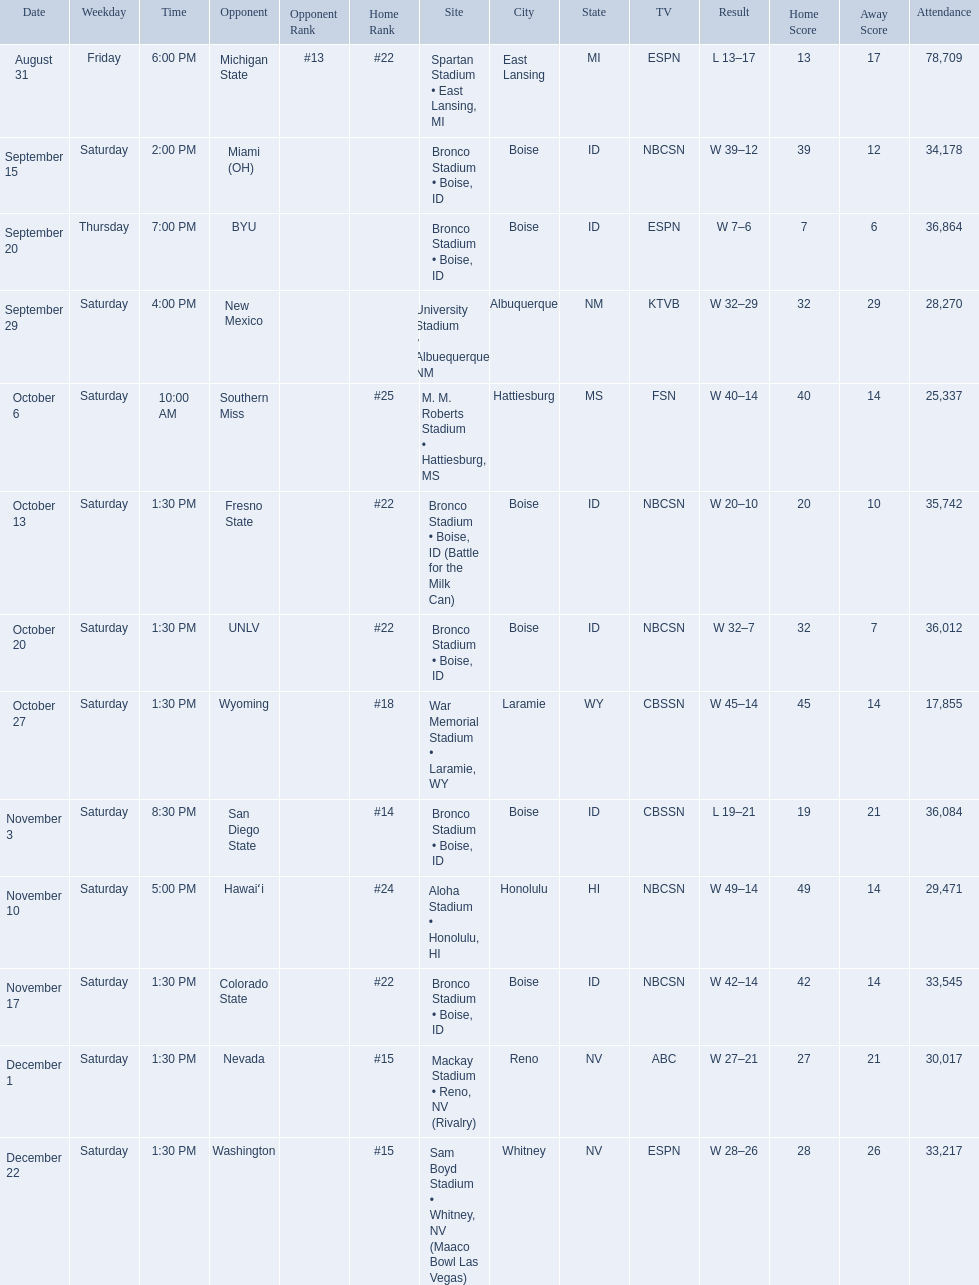Who were all of the opponents? At #13 michigan state*, miami (oh)*, byu*, at new mexico, at southern miss*, fresno state, unlv, at wyoming, san diego state, at hawaiʻi, colorado state, at nevada, vs. washington*. Who did they face on november 3rd? San Diego State. Can you parse all the data within this table? {'header': ['Date', 'Weekday', 'Time', 'Opponent', 'Opponent Rank', 'Home Rank', 'Site', 'City', 'State', 'TV', 'Result', 'Home Score', 'Away Score', 'Attendance'], 'rows': [['August 31', 'Friday', '6:00 PM', 'Michigan State', '#13', '#22', 'Spartan Stadium • East Lansing, MI', 'East Lansing', 'MI', 'ESPN', 'L\xa013–17', '13', '17', '78,709'], ['September 15', 'Saturday', '2:00 PM', 'Miami (OH)', '', '', 'Bronco Stadium • Boise, ID', 'Boise', 'ID', 'NBCSN', 'W\xa039–12', '39', '12', '34,178'], ['September 20', 'Thursday', '7:00 PM', 'BYU', '', '', 'Bronco Stadium • Boise, ID', 'Boise', 'ID', 'ESPN', 'W\xa07–6', '7', '6', '36,864'], ['September 29', 'Saturday', '4:00 PM', 'New Mexico', '', '', 'University Stadium • Albuequerque, NM', 'Albuquerque', 'NM', 'KTVB', 'W\xa032–29', '32', '29', '28,270'], ['October 6', 'Saturday', '10:00 AM', 'Southern Miss', '', '#25', 'M. M. Roberts Stadium • Hattiesburg, MS', 'Hattiesburg', 'MS', 'FSN', 'W\xa040–14', '40', '14', '25,337'], ['October 13', 'Saturday', '1:30 PM', 'Fresno State', '', '#22', 'Bronco Stadium • Boise, ID (Battle for the Milk Can)', 'Boise', 'ID', 'NBCSN', 'W\xa020–10', '20', '10', '35,742'], ['October 20', 'Saturday', '1:30 PM', 'UNLV', '', '#22', 'Bronco Stadium • Boise, ID', 'Boise', 'ID', 'NBCSN', 'W\xa032–7', '32', '7', '36,012'], ['October 27', 'Saturday', '1:30 PM', 'Wyoming', '', '#18', 'War Memorial Stadium • Laramie, WY', 'Laramie', 'WY', 'CBSSN', 'W\xa045–14', '45', '14', '17,855'], ['November 3', 'Saturday', '8:30 PM', 'San Diego State', '', '#14', 'Bronco Stadium • Boise, ID', 'Boise', 'ID', 'CBSSN', 'L\xa019–21', '19', '21', '36,084'], ['November 10', 'Saturday', '5:00 PM', 'Hawaiʻi', '', '#24', 'Aloha Stadium • Honolulu, HI', 'Honolulu', 'HI', 'NBCSN', 'W\xa049–14', '49', '14', '29,471'], ['November 17', 'Saturday', '1:30 PM', 'Colorado State', '', '#22', 'Bronco Stadium • Boise, ID', 'Boise', 'ID', 'NBCSN', 'W\xa042–14', '42', '14', '33,545'], ['December 1', 'Saturday', '1:30 PM', 'Nevada', '', '#15', 'Mackay Stadium • Reno, NV (Rivalry)', 'Reno', 'NV', 'ABC', 'W\xa027–21', '27', '21', '30,017'], ['December 22', 'Saturday', '1:30 PM', 'Washington', '', '#15', 'Sam Boyd Stadium • Whitney, NV (Maaco Bowl Las Vegas)', 'Whitney', 'NV', 'ESPN', 'W\xa028–26', '28', '26', '33,217']]} What rank were they on november 3rd? #14. 